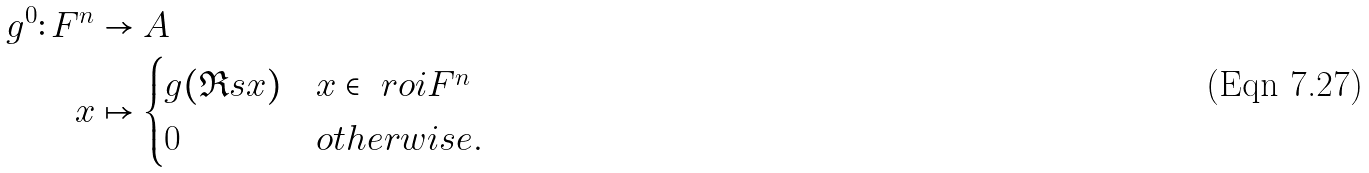<formula> <loc_0><loc_0><loc_500><loc_500>g ^ { 0 } \colon F ^ { n } & \to A \\ x & \mapsto \begin{cases} g ( \Re s { x } ) & x \in \ r o i { F } ^ { n } \\ 0 & o t h e r w i s e . \end{cases}</formula> 